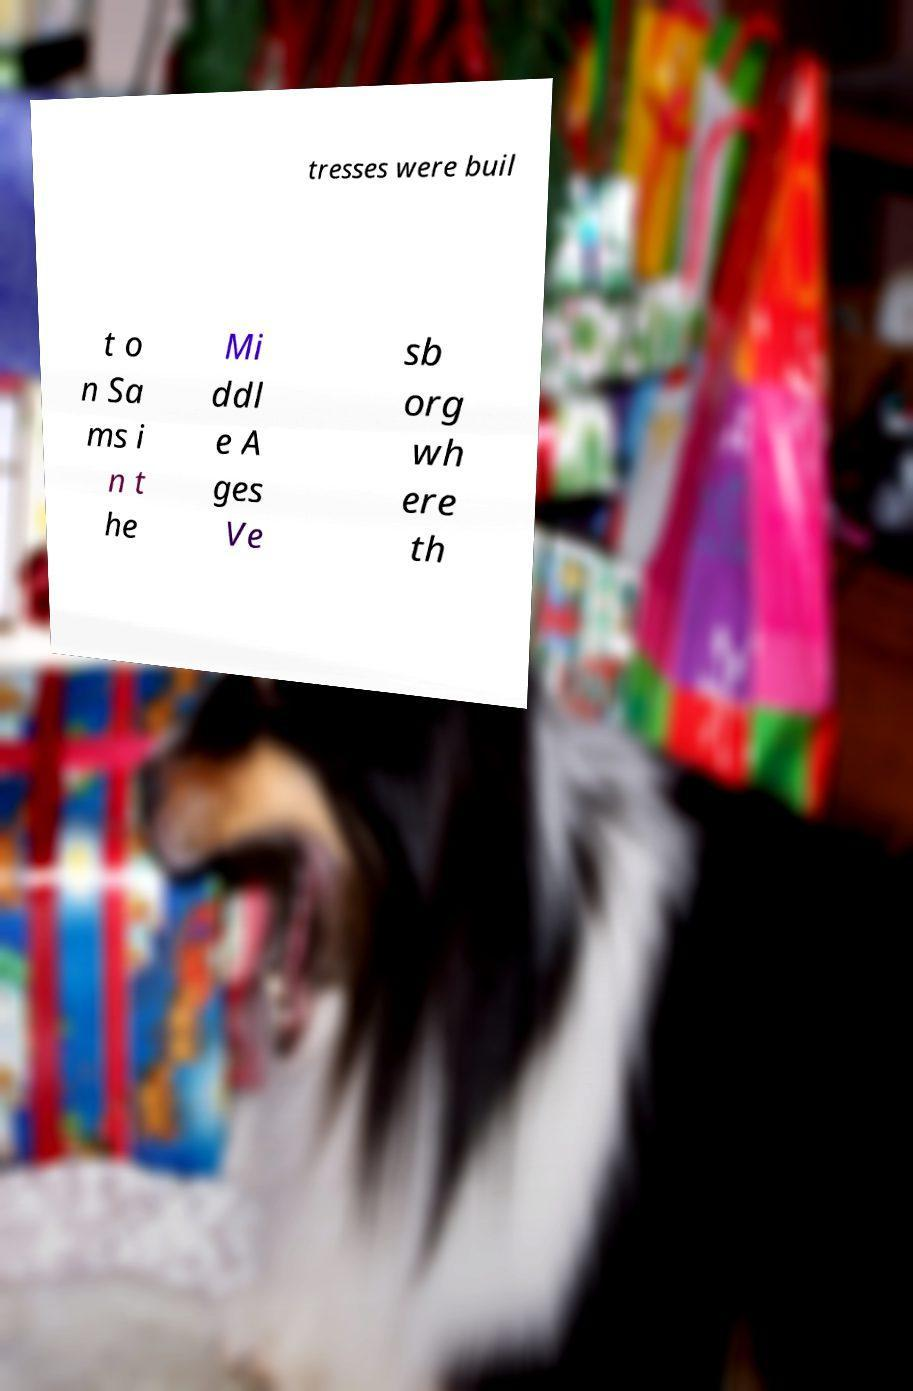What messages or text are displayed in this image? I need them in a readable, typed format. tresses were buil t o n Sa ms i n t he Mi ddl e A ges Ve sb org wh ere th 